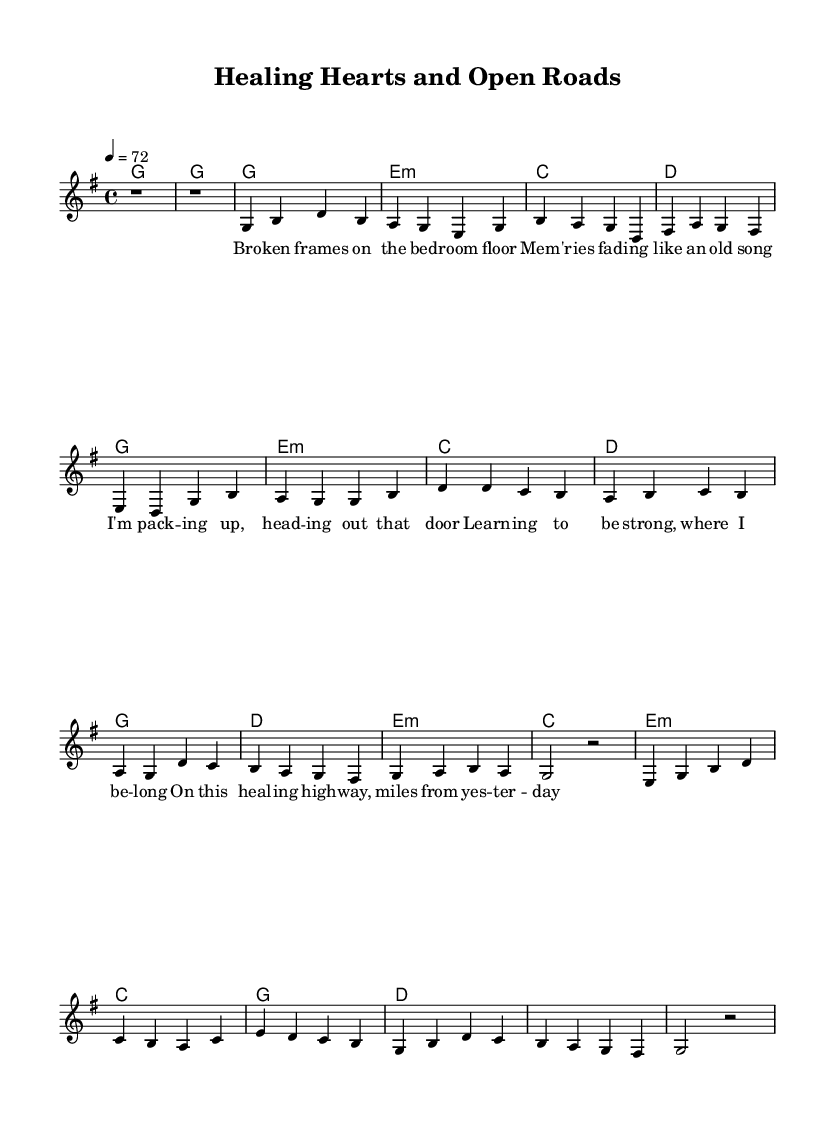What is the key signature of this music? The key signature is G major, which has one sharp (F#). This can be identified by looking at the key signature section at the beginning of the sheet music.
Answer: G major What is the time signature of this music? The time signature is 4/4, as indicated at the start of the score. This means there are four beats in each measure, and the quarter note receives one beat.
Answer: 4/4 What is the tempo marking for the piece? The tempo marking is 72 beats per minute, indicated by the notation "4 = 72". This shows that a quarter note is played at this speed.
Answer: 72 How many verses are present in the song? There is one verse included in the sheet music. The verse is indicated by the lyrics and is laid out before the chorus.
Answer: One verse What is the main thematic focus of the lyrics? The lyrics focus on themes of heartbreak and personal growth, as suggested by phrases like "broken frames" and "learning to be strong." This aligns with the emotional context typical in country ballads.
Answer: Heartbreak and personal growth Which chord is used in the chorus section? The chords used in the chorus include G, D, E minor, and C, all of which are common in country songs and contribute to the heartfelt sound typical in the genre.
Answer: G, D, E minor, C 